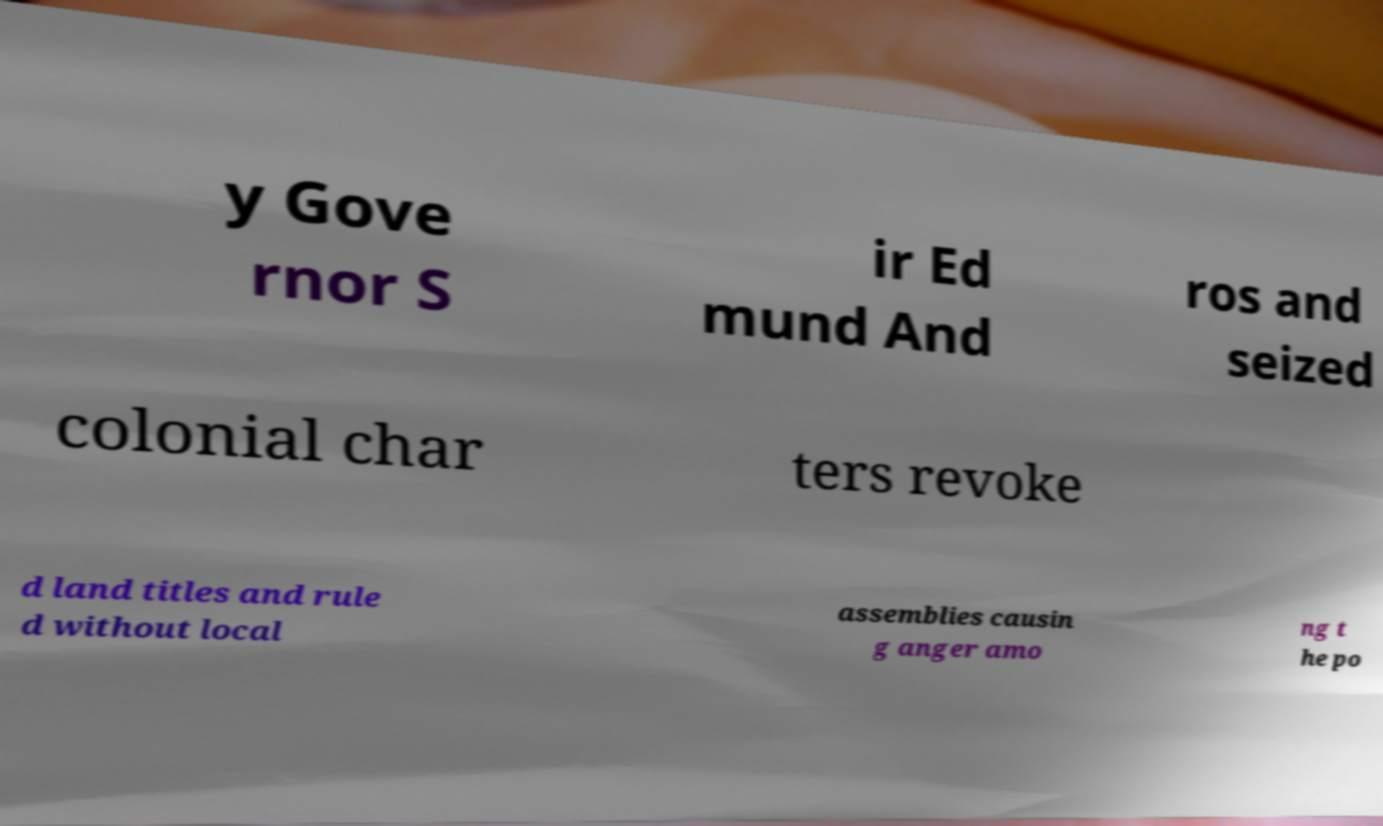Could you assist in decoding the text presented in this image and type it out clearly? y Gove rnor S ir Ed mund And ros and seized colonial char ters revoke d land titles and rule d without local assemblies causin g anger amo ng t he po 